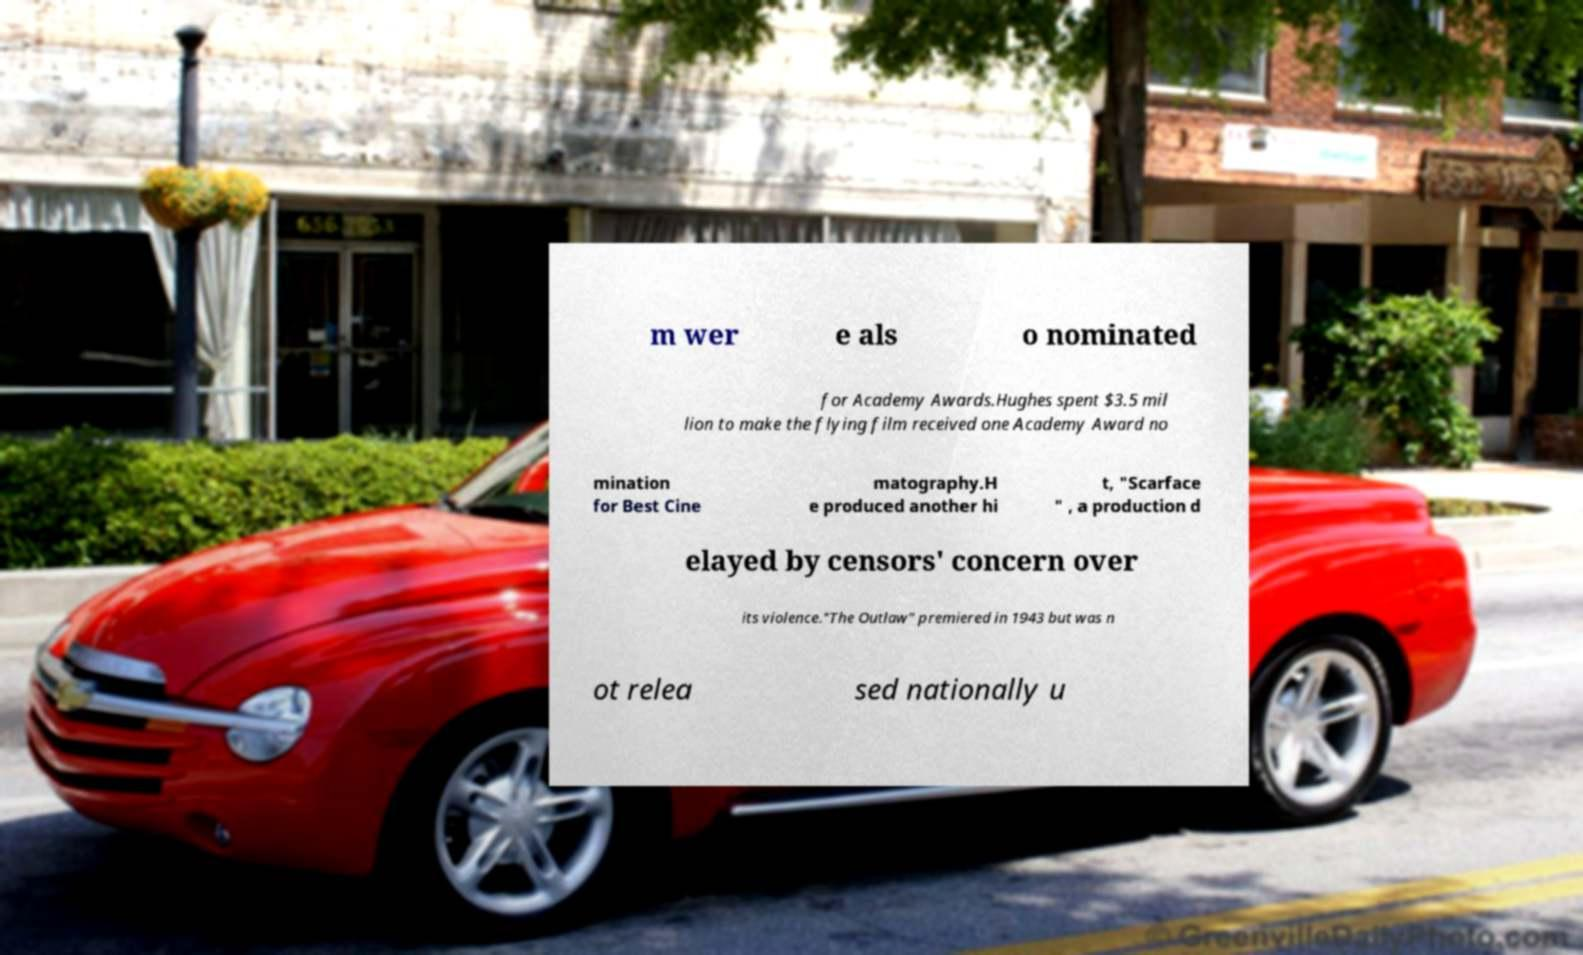Can you read and provide the text displayed in the image?This photo seems to have some interesting text. Can you extract and type it out for me? m wer e als o nominated for Academy Awards.Hughes spent $3.5 mil lion to make the flying film received one Academy Award no mination for Best Cine matography.H e produced another hi t, "Scarface " , a production d elayed by censors' concern over its violence."The Outlaw" premiered in 1943 but was n ot relea sed nationally u 